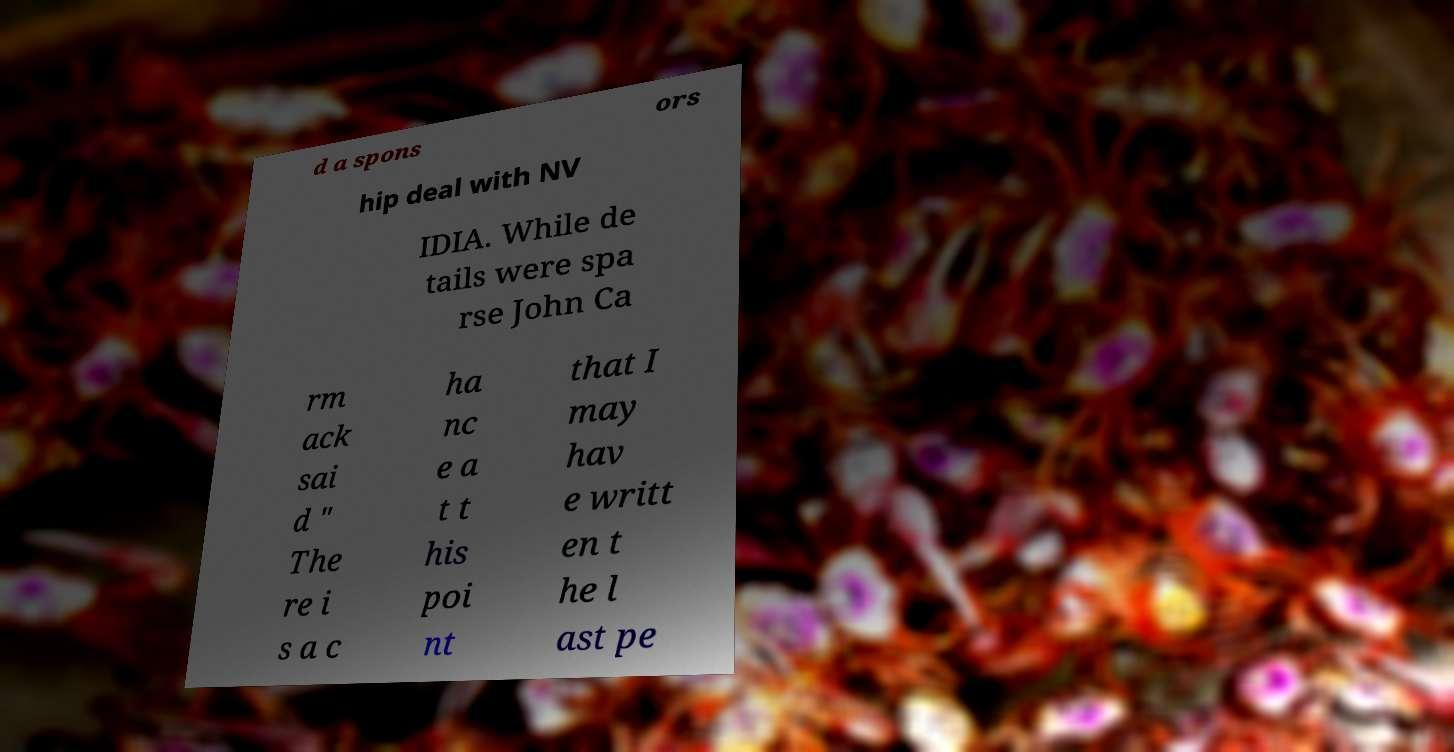Could you assist in decoding the text presented in this image and type it out clearly? d a spons ors hip deal with NV IDIA. While de tails were spa rse John Ca rm ack sai d " The re i s a c ha nc e a t t his poi nt that I may hav e writt en t he l ast pe 